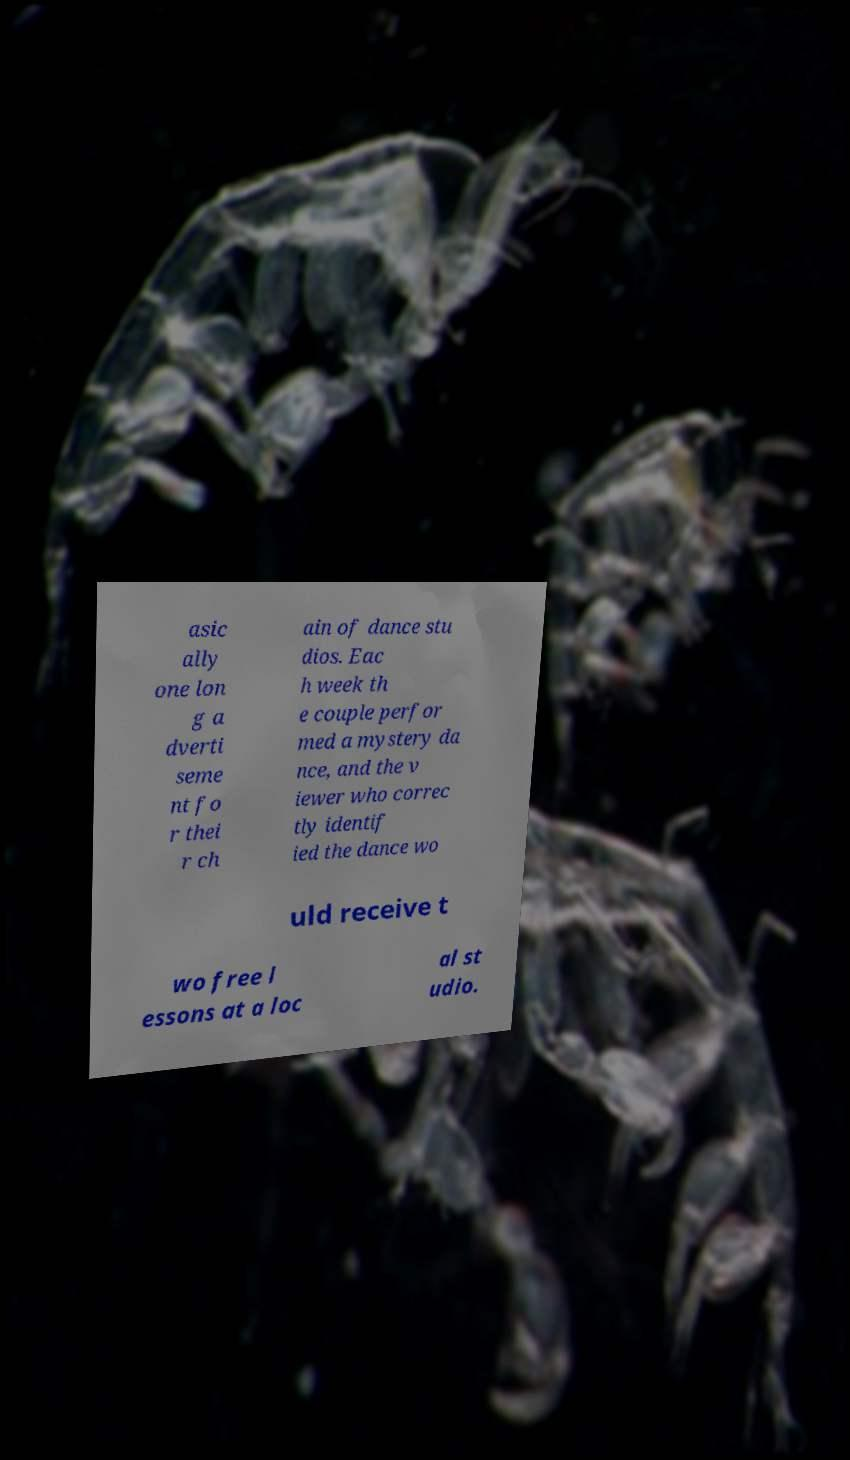Could you extract and type out the text from this image? asic ally one lon g a dverti seme nt fo r thei r ch ain of dance stu dios. Eac h week th e couple perfor med a mystery da nce, and the v iewer who correc tly identif ied the dance wo uld receive t wo free l essons at a loc al st udio. 